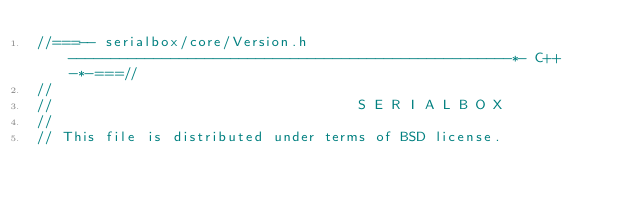<code> <loc_0><loc_0><loc_500><loc_500><_C_>//===-- serialbox/core/Version.h ----------------------------------------------------*- C++ -*-===//
//
//                                    S E R I A L B O X
//
// This file is distributed under terms of BSD license.</code> 